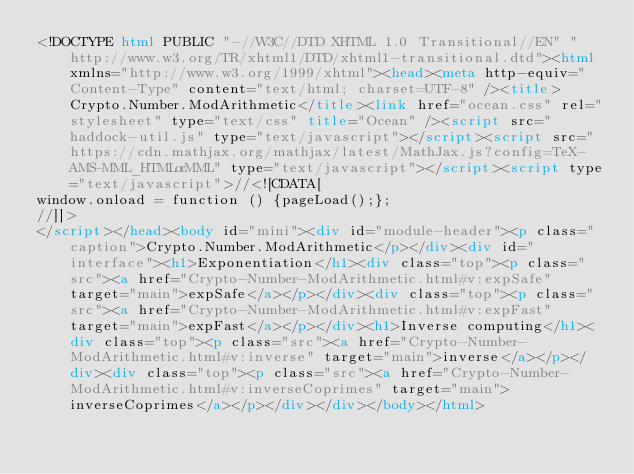<code> <loc_0><loc_0><loc_500><loc_500><_HTML_><!DOCTYPE html PUBLIC "-//W3C//DTD XHTML 1.0 Transitional//EN" "http://www.w3.org/TR/xhtml1/DTD/xhtml1-transitional.dtd"><html xmlns="http://www.w3.org/1999/xhtml"><head><meta http-equiv="Content-Type" content="text/html; charset=UTF-8" /><title>Crypto.Number.ModArithmetic</title><link href="ocean.css" rel="stylesheet" type="text/css" title="Ocean" /><script src="haddock-util.js" type="text/javascript"></script><script src="https://cdn.mathjax.org/mathjax/latest/MathJax.js?config=TeX-AMS-MML_HTMLorMML" type="text/javascript"></script><script type="text/javascript">//<![CDATA[
window.onload = function () {pageLoad();};
//]]>
</script></head><body id="mini"><div id="module-header"><p class="caption">Crypto.Number.ModArithmetic</p></div><div id="interface"><h1>Exponentiation</h1><div class="top"><p class="src"><a href="Crypto-Number-ModArithmetic.html#v:expSafe" target="main">expSafe</a></p></div><div class="top"><p class="src"><a href="Crypto-Number-ModArithmetic.html#v:expFast" target="main">expFast</a></p></div><h1>Inverse computing</h1><div class="top"><p class="src"><a href="Crypto-Number-ModArithmetic.html#v:inverse" target="main">inverse</a></p></div><div class="top"><p class="src"><a href="Crypto-Number-ModArithmetic.html#v:inverseCoprimes" target="main">inverseCoprimes</a></p></div></div></body></html></code> 